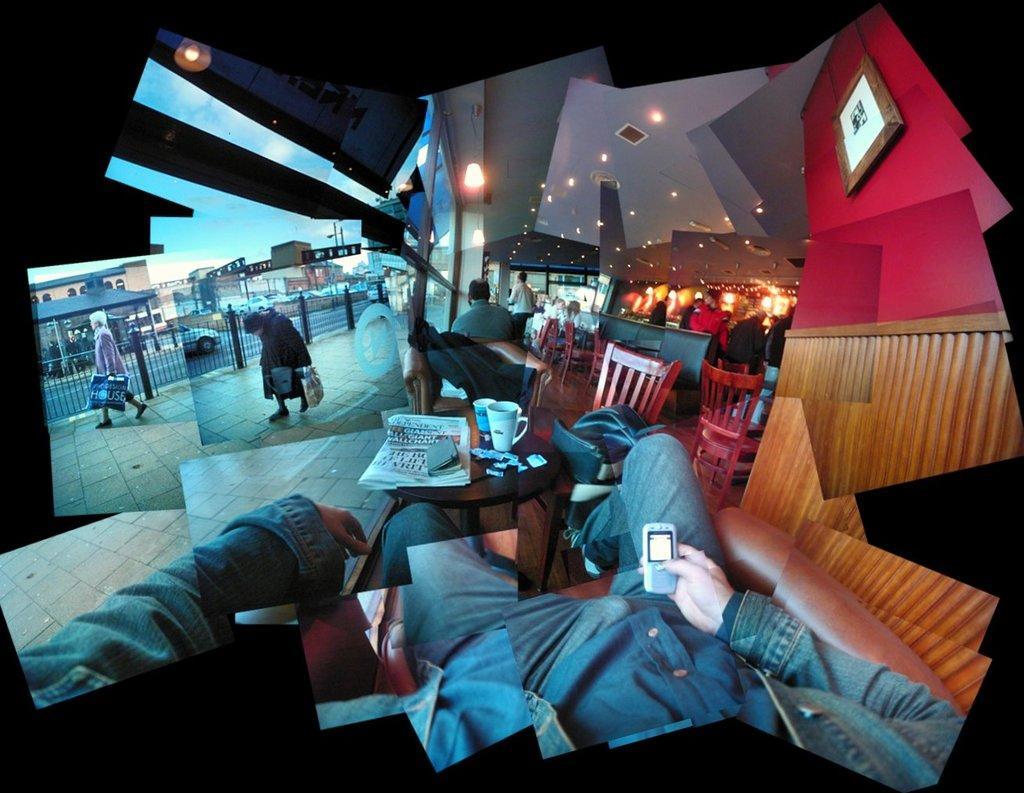Could you give a brief overview of what you see in this image? This is a collage image of so many pictures in which people are walking on the pavement and a person sitting in a restaurant. 